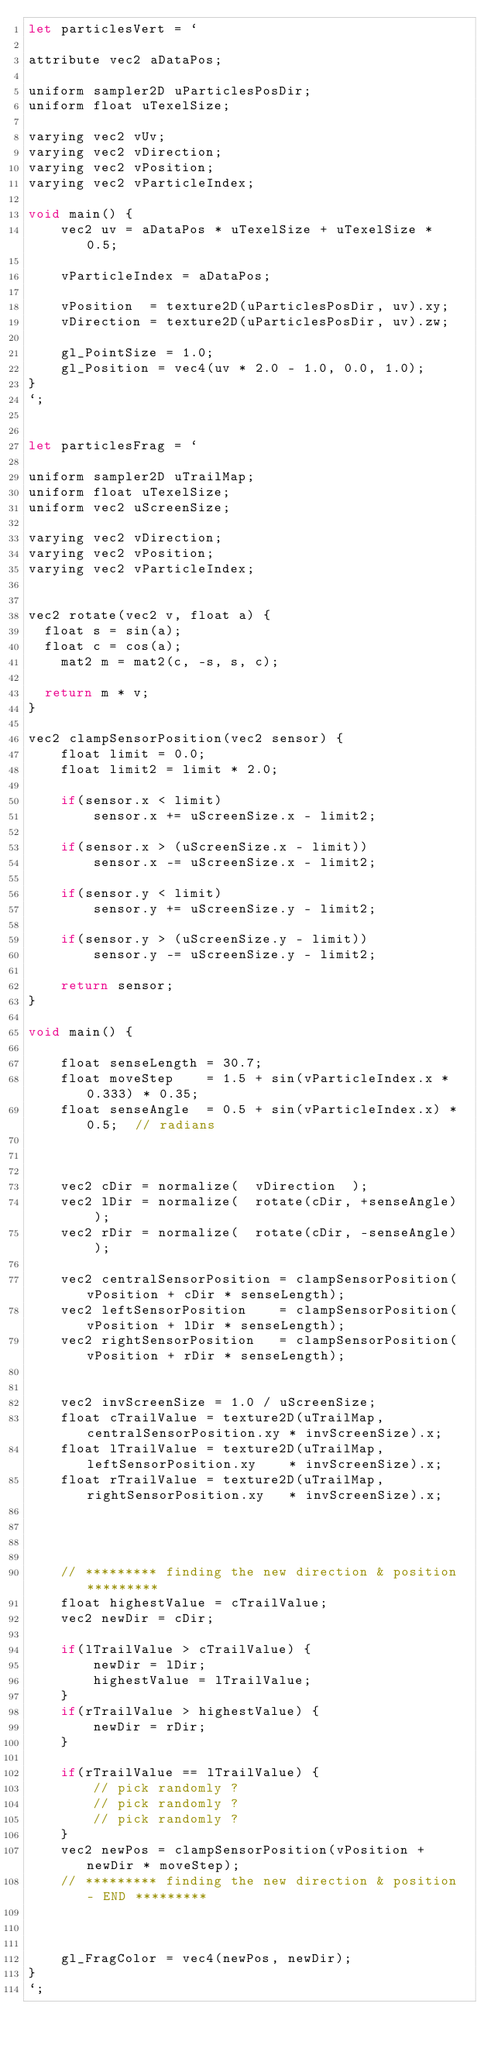<code> <loc_0><loc_0><loc_500><loc_500><_JavaScript_>let particlesVert = `

attribute vec2 aDataPos;

uniform sampler2D uParticlesPosDir;
uniform float uTexelSize;

varying vec2 vUv;
varying vec2 vDirection;
varying vec2 vPosition;
varying vec2 vParticleIndex;

void main() {
    vec2 uv = aDataPos * uTexelSize + uTexelSize * 0.5;

    vParticleIndex = aDataPos;

    vPosition  = texture2D(uParticlesPosDir, uv).xy;
    vDirection = texture2D(uParticlesPosDir, uv).zw;

    gl_PointSize = 1.0;
    gl_Position = vec4(uv * 2.0 - 1.0, 0.0, 1.0);
}
`;


let particlesFrag = `

uniform sampler2D uTrailMap;
uniform float uTexelSize;
uniform vec2 uScreenSize;

varying vec2 vDirection;
varying vec2 vPosition;
varying vec2 vParticleIndex;


vec2 rotate(vec2 v, float a) {
	float s = sin(a);
	float c = cos(a);
    mat2 m = mat2(c, -s, s, c);
    
	return m * v;
}

vec2 clampSensorPosition(vec2 sensor) {
    float limit = 0.0;
    float limit2 = limit * 2.0;

    if(sensor.x < limit)         
        sensor.x += uScreenSize.x - limit2;
        
    if(sensor.x > (uScreenSize.x - limit))
        sensor.x -= uScreenSize.x - limit2;

    if(sensor.y < limit)           
        sensor.y += uScreenSize.y - limit2;

    if(sensor.y > (uScreenSize.y - limit)) 
        sensor.y -= uScreenSize.y - limit2;

    return sensor;
}

void main() {

    float senseLength = 30.7;
    float moveStep    = 1.5 + sin(vParticleIndex.x * 0.333) * 0.35;  
    float senseAngle  = 0.5 + sin(vParticleIndex.x) * 0.5;  // radians



    vec2 cDir = normalize(  vDirection  );
    vec2 lDir = normalize(  rotate(cDir, +senseAngle)  );
    vec2 rDir = normalize(  rotate(cDir, -senseAngle)  );

    vec2 centralSensorPosition = clampSensorPosition(vPosition + cDir * senseLength);
    vec2 leftSensorPosition    = clampSensorPosition(vPosition + lDir * senseLength);
    vec2 rightSensorPosition   = clampSensorPosition(vPosition + rDir * senseLength);


    vec2 invScreenSize = 1.0 / uScreenSize;
    float cTrailValue = texture2D(uTrailMap, centralSensorPosition.xy * invScreenSize).x;   
    float lTrailValue = texture2D(uTrailMap, leftSensorPosition.xy    * invScreenSize).x;   
    float rTrailValue = texture2D(uTrailMap, rightSensorPosition.xy   * invScreenSize).x;   




    // ********* finding the new direction & position *********
    float highestValue = cTrailValue;
    vec2 newDir = cDir;

    if(lTrailValue > cTrailValue) {
        newDir = lDir;
        highestValue = lTrailValue;
    }
    if(rTrailValue > highestValue) {
        newDir = rDir;
    }

    if(rTrailValue == lTrailValue) {
        // pick randomly ?
        // pick randomly ?
        // pick randomly ?
    }
    vec2 newPos = clampSensorPosition(vPosition + newDir * moveStep);
    // ********* finding the new direction & position - END *********



    gl_FragColor = vec4(newPos, newDir);
}
`;


</code> 